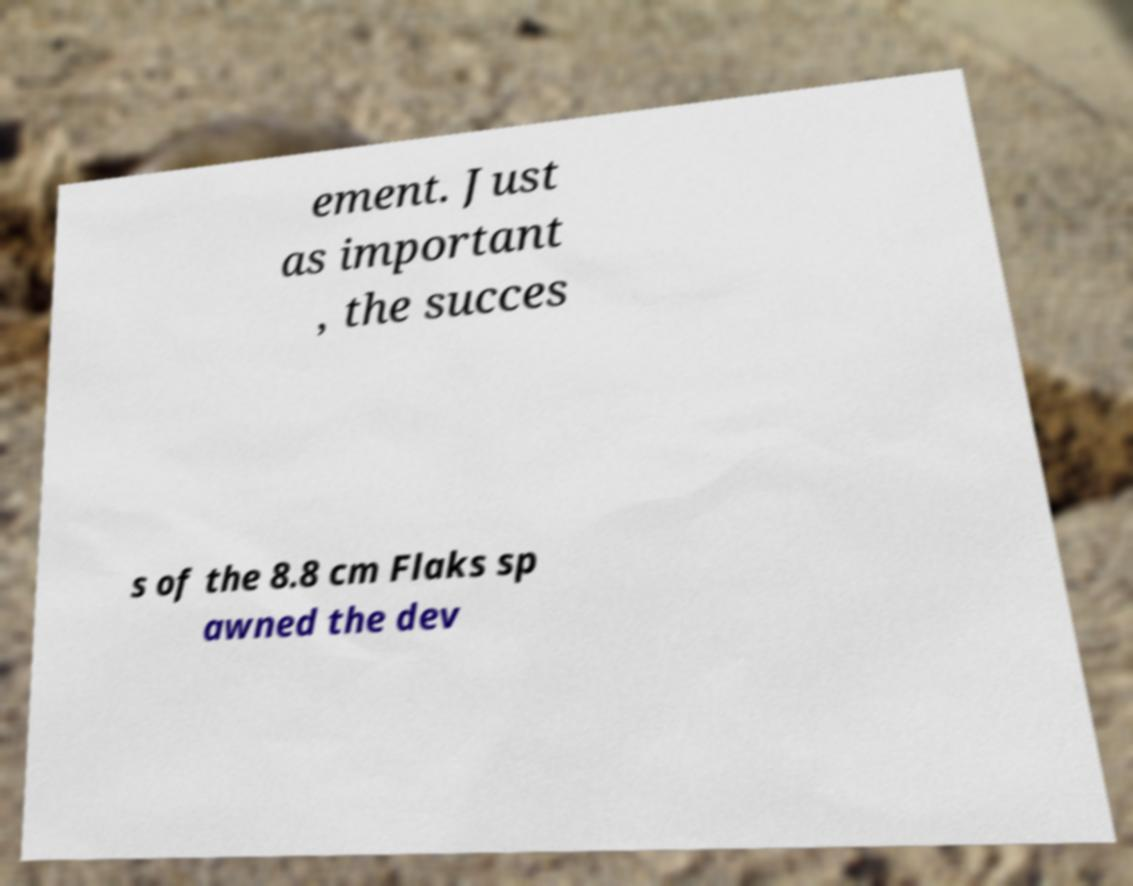I need the written content from this picture converted into text. Can you do that? ement. Just as important , the succes s of the 8.8 cm Flaks sp awned the dev 